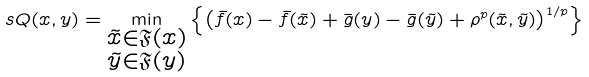Convert formula to latex. <formula><loc_0><loc_0><loc_500><loc_500>\ s Q ( x , y ) = \min _ { \substack { \tilde { x } \in \mathfrak { F } ( x ) \\ \tilde { y } \in \mathfrak { F } ( y ) } } \left \{ \left ( \bar { f } ( x ) - \bar { f } ( \tilde { x } ) + \bar { g } ( y ) - \bar { g } ( \tilde { y } ) + \rho ^ { p } ( \tilde { x } , \tilde { y } ) \right ) ^ { 1 / p } \right \}</formula> 